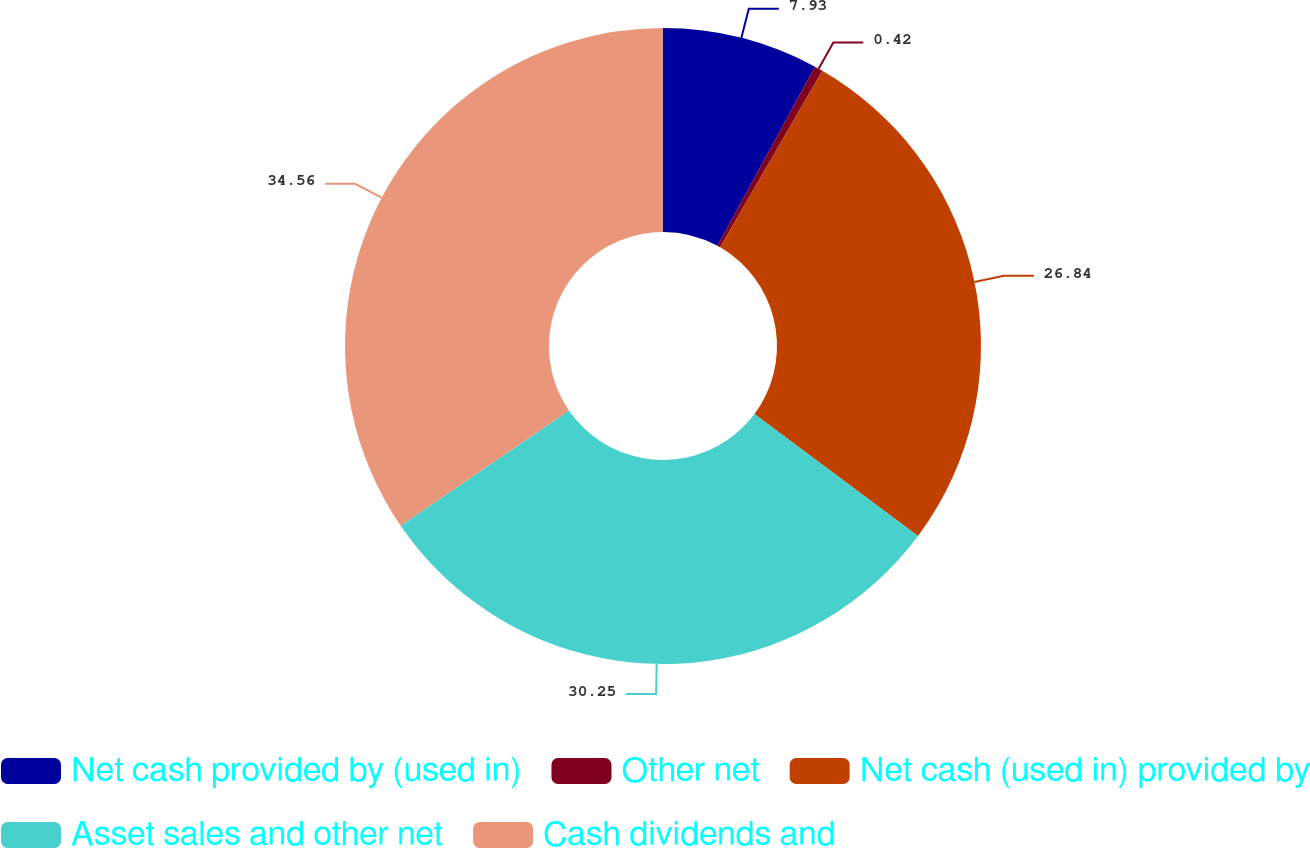<chart> <loc_0><loc_0><loc_500><loc_500><pie_chart><fcel>Net cash provided by (used in)<fcel>Other net<fcel>Net cash (used in) provided by<fcel>Asset sales and other net<fcel>Cash dividends and<nl><fcel>7.93%<fcel>0.42%<fcel>26.84%<fcel>30.25%<fcel>34.56%<nl></chart> 